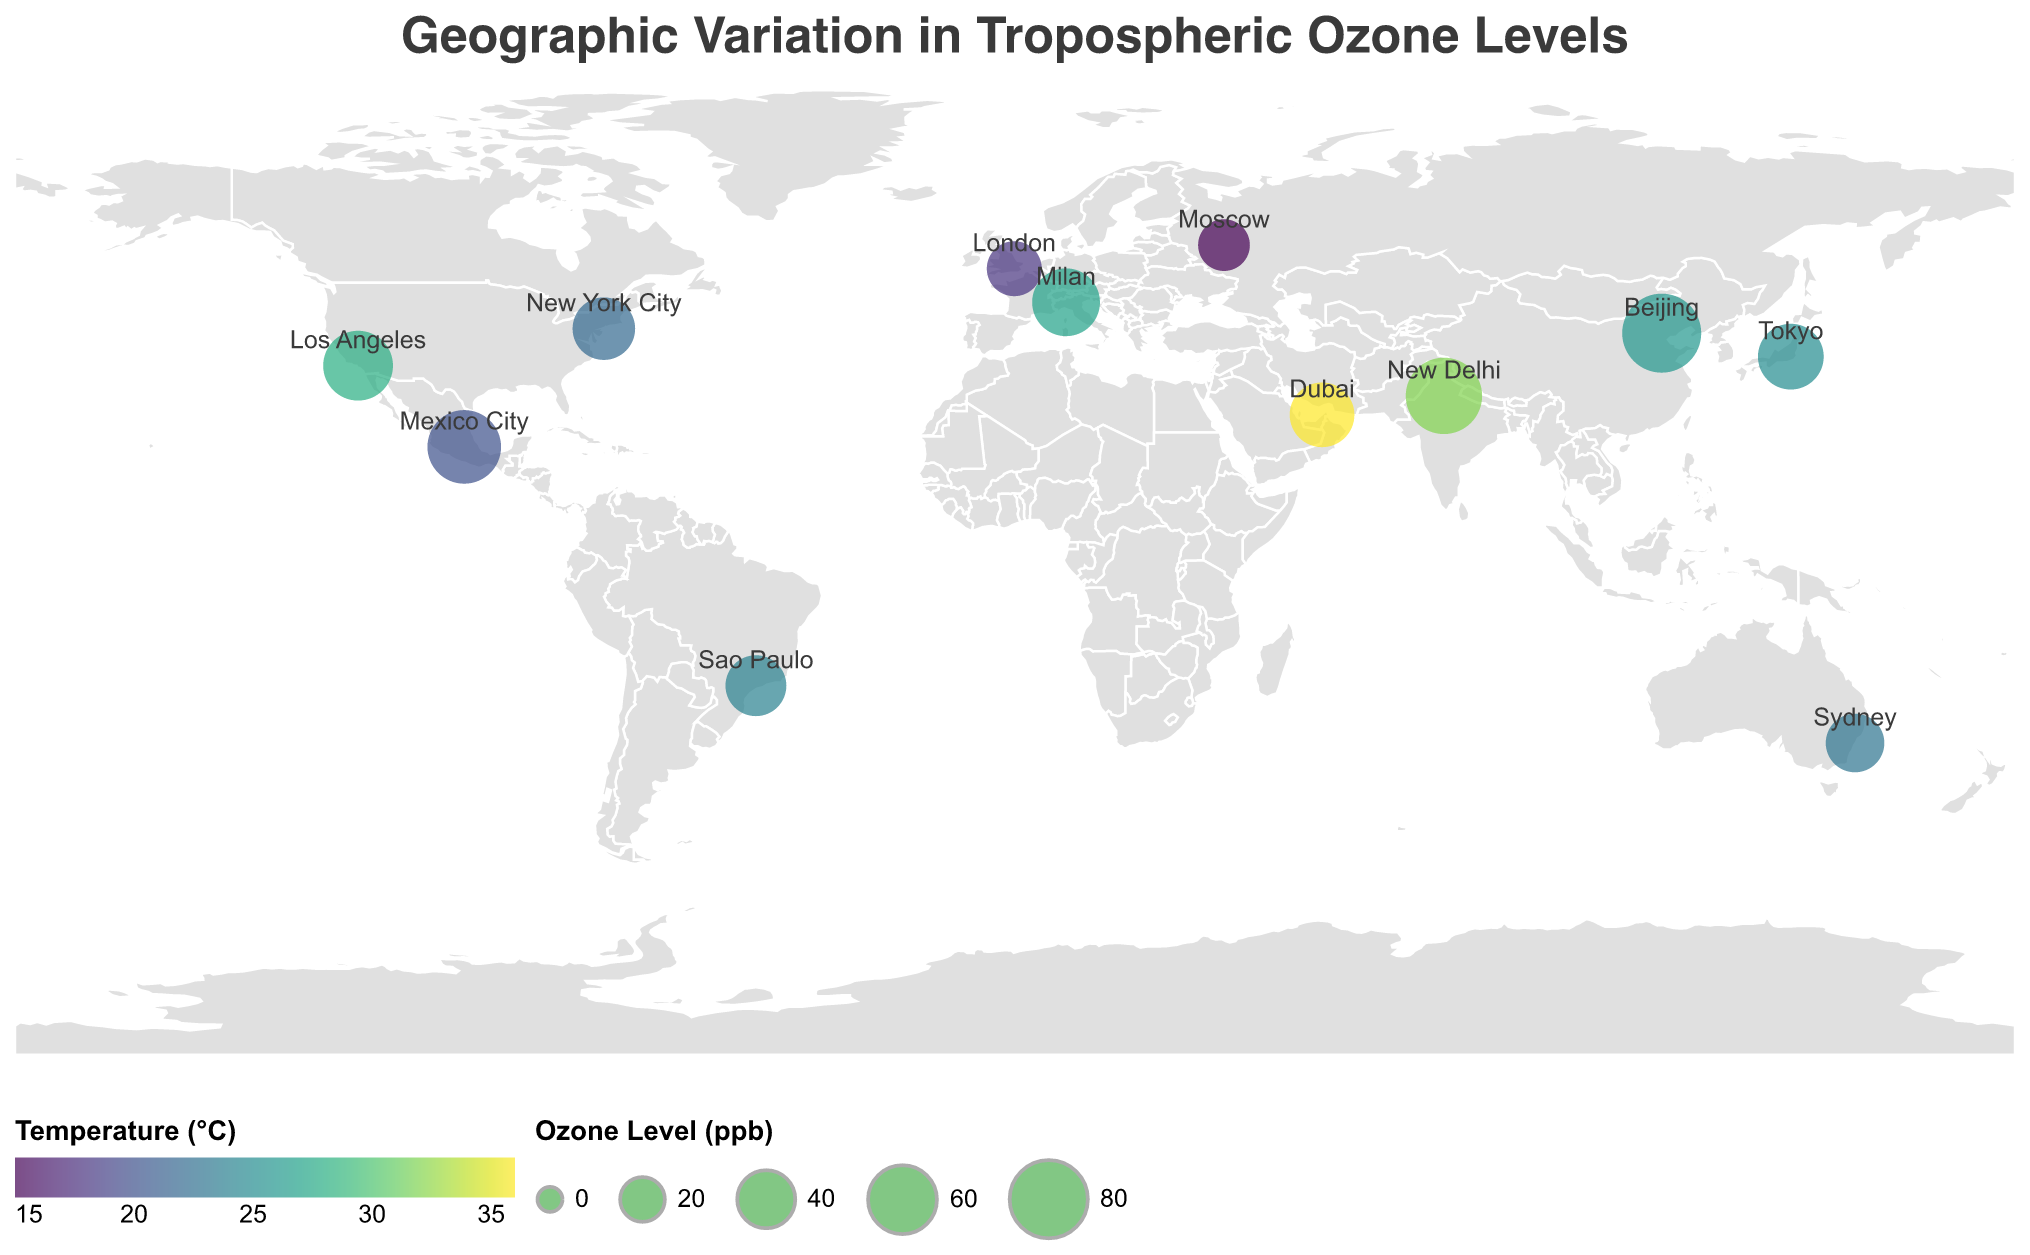What is the title of the plot? The plot title is displayed at the top as "Geographic Variation in Tropospheric Ozone Levels".
Answer: Geographic Variation in Tropospheric Ozone Levels What does the color of the circles represent in the plot? According to the legend, the color of the circles represents the temperature in degrees Celsius. The scale ranges from a scheme known as "viridis".
Answer: Temperature (°C) Which city has the highest ozone level? By inspecting the size of the circles and their corresponding data, the largest circle represents the highest ozone level which is for Beijing with an ozone level of 82 ppb.
Answer: Beijing What temperature is associated with Los Angeles? By looking at the color and corresponding data for Los Angeles, the temperature for Los Angeles is 28°C.
Answer: 28°C What is the correlation coefficient for Mexico City? The correlation coefficient for Mexico City is 0.89 as shown in its data tooltip.
Answer: 0.89 Which cities have an ozone level greater than 60 ppb? By observing the size of the circles and their data, the cities with an ozone level greater than 60 ppb are Los Angeles, Mexico City, Beijing, New Delhi, and Milan.
Answer: Los Angeles, Mexico City, Beijing, New Delhi, Milan Between Sydney and Dubai, which has a higher temperature? By comparing the color of the circles and referencing their data, Dubai has a higher temperature (36°C) compared to Sydney (23°C).
Answer: Dubai Calculate the average ozone level of New York City, London, and Tokyo. The ozone levels are New York City (48 ppb), London (35 ppb), and Tokyo (54 ppb). The average is (48 + 35 + 54) / 3 = 137 / 3 ≈ 45.67 ppb.
Answer: 45.67 ppb Which city shows the lowest correlation coefficient between ozone level and temperature? By checking the correlation coefficients, the lowest value is for Moscow with a correlation coefficient of 0.68.
Answer: Moscow What can you deduce about the relationship between ozone levels and temperature in Beijing? Beijing has the highest ozone level (82 ppb) and a high correlation coefficient (0.92), indicating a strong positive correlation between ozone level and temperature.
Answer: Strong positive correlation 